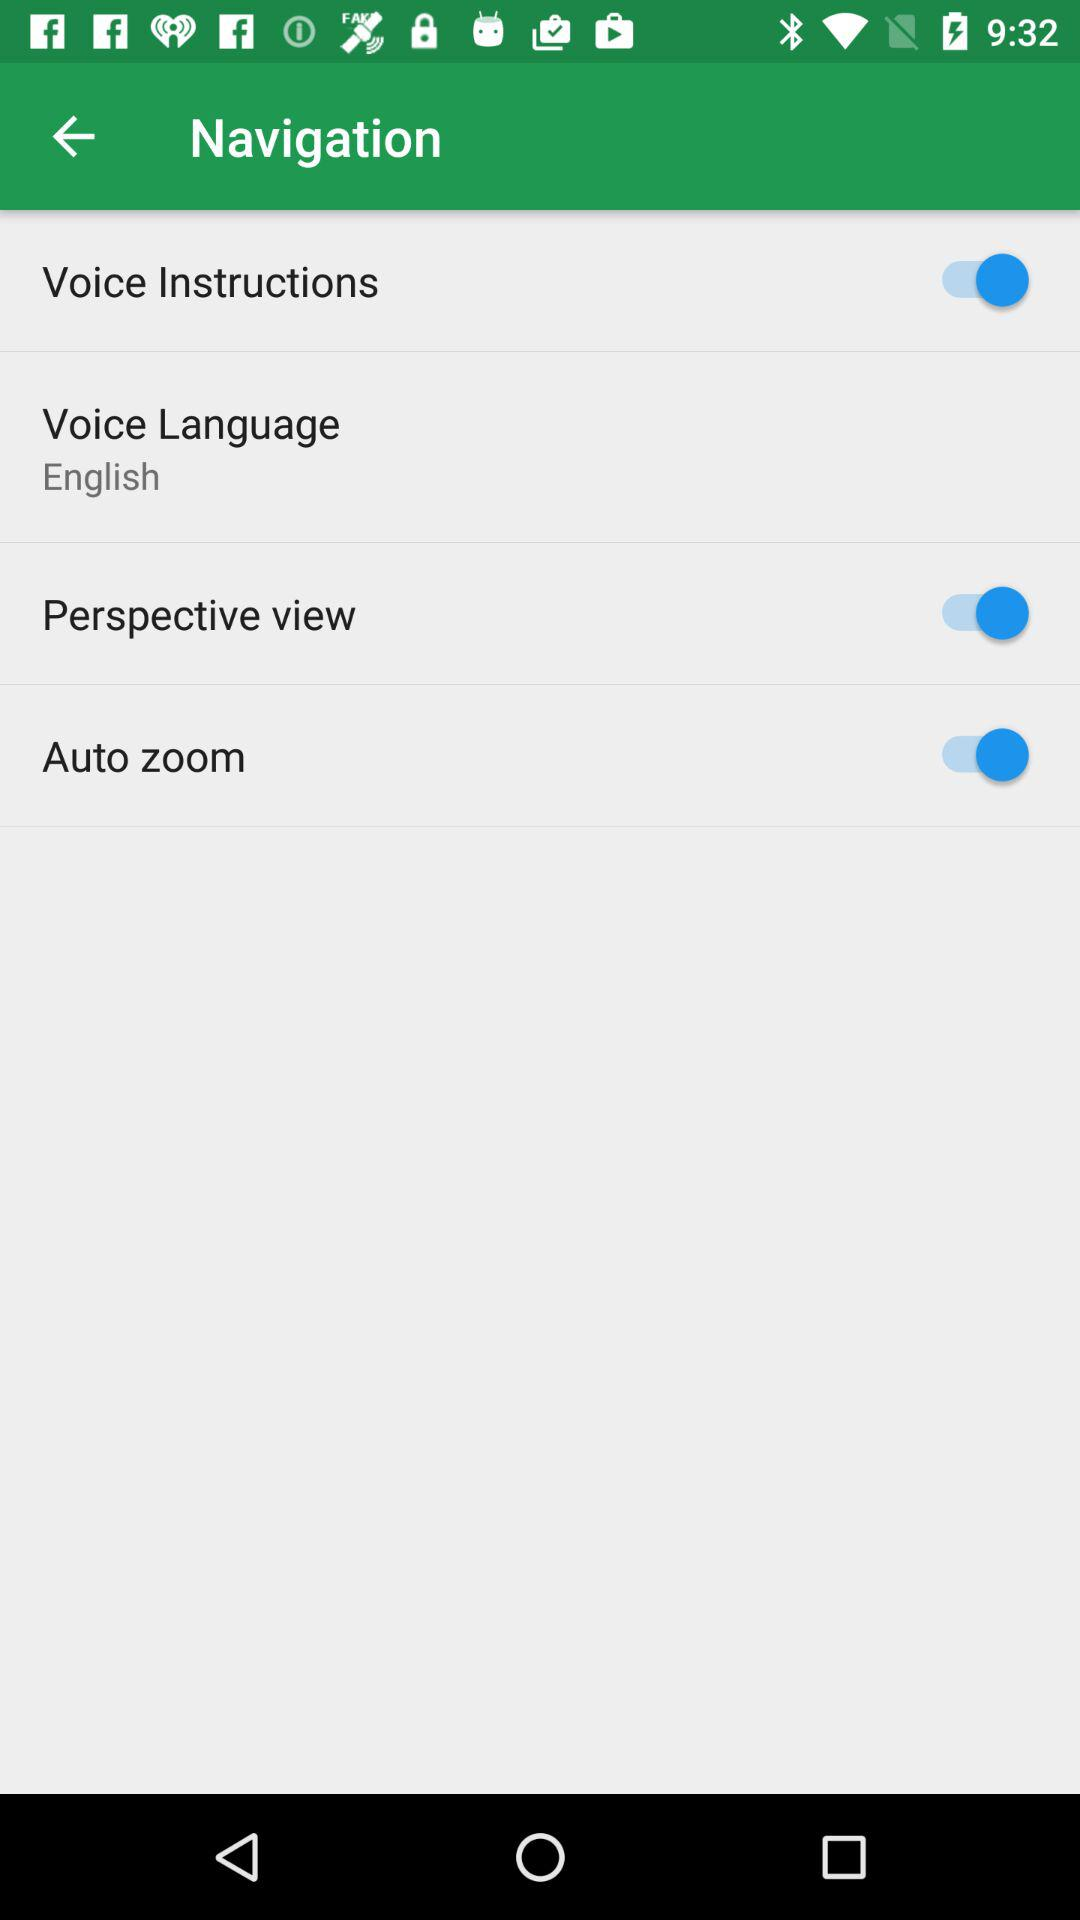How many of the items have a switch?
Answer the question using a single word or phrase. 3 